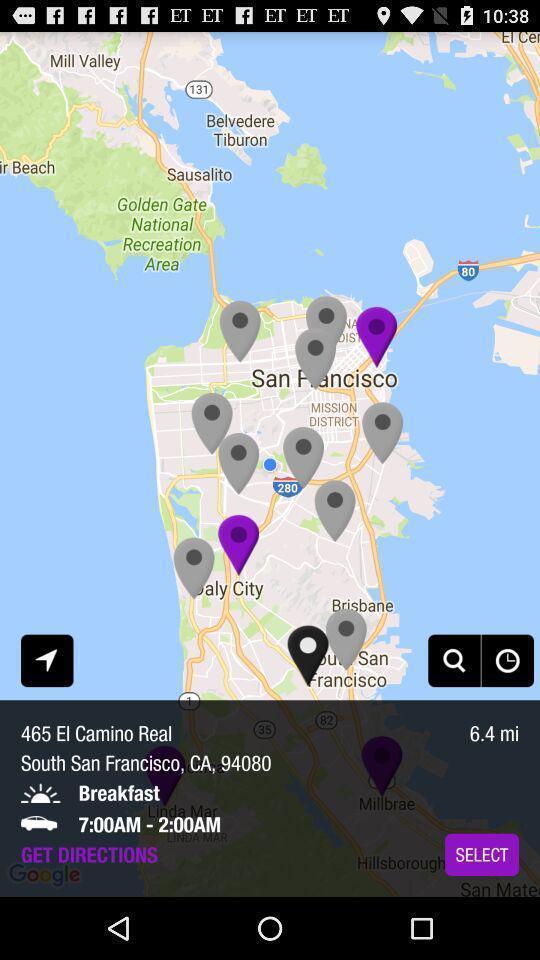Summarize the main components in this picture. Screen displaying a map view of a particular location. 